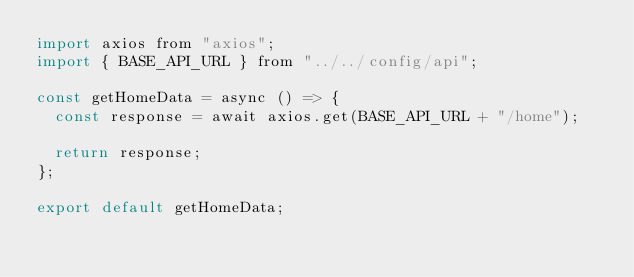<code> <loc_0><loc_0><loc_500><loc_500><_JavaScript_>import axios from "axios";
import { BASE_API_URL } from "../../config/api";

const getHomeData = async () => {
  const response = await axios.get(BASE_API_URL + "/home");

  return response;
};

export default getHomeData;</code> 